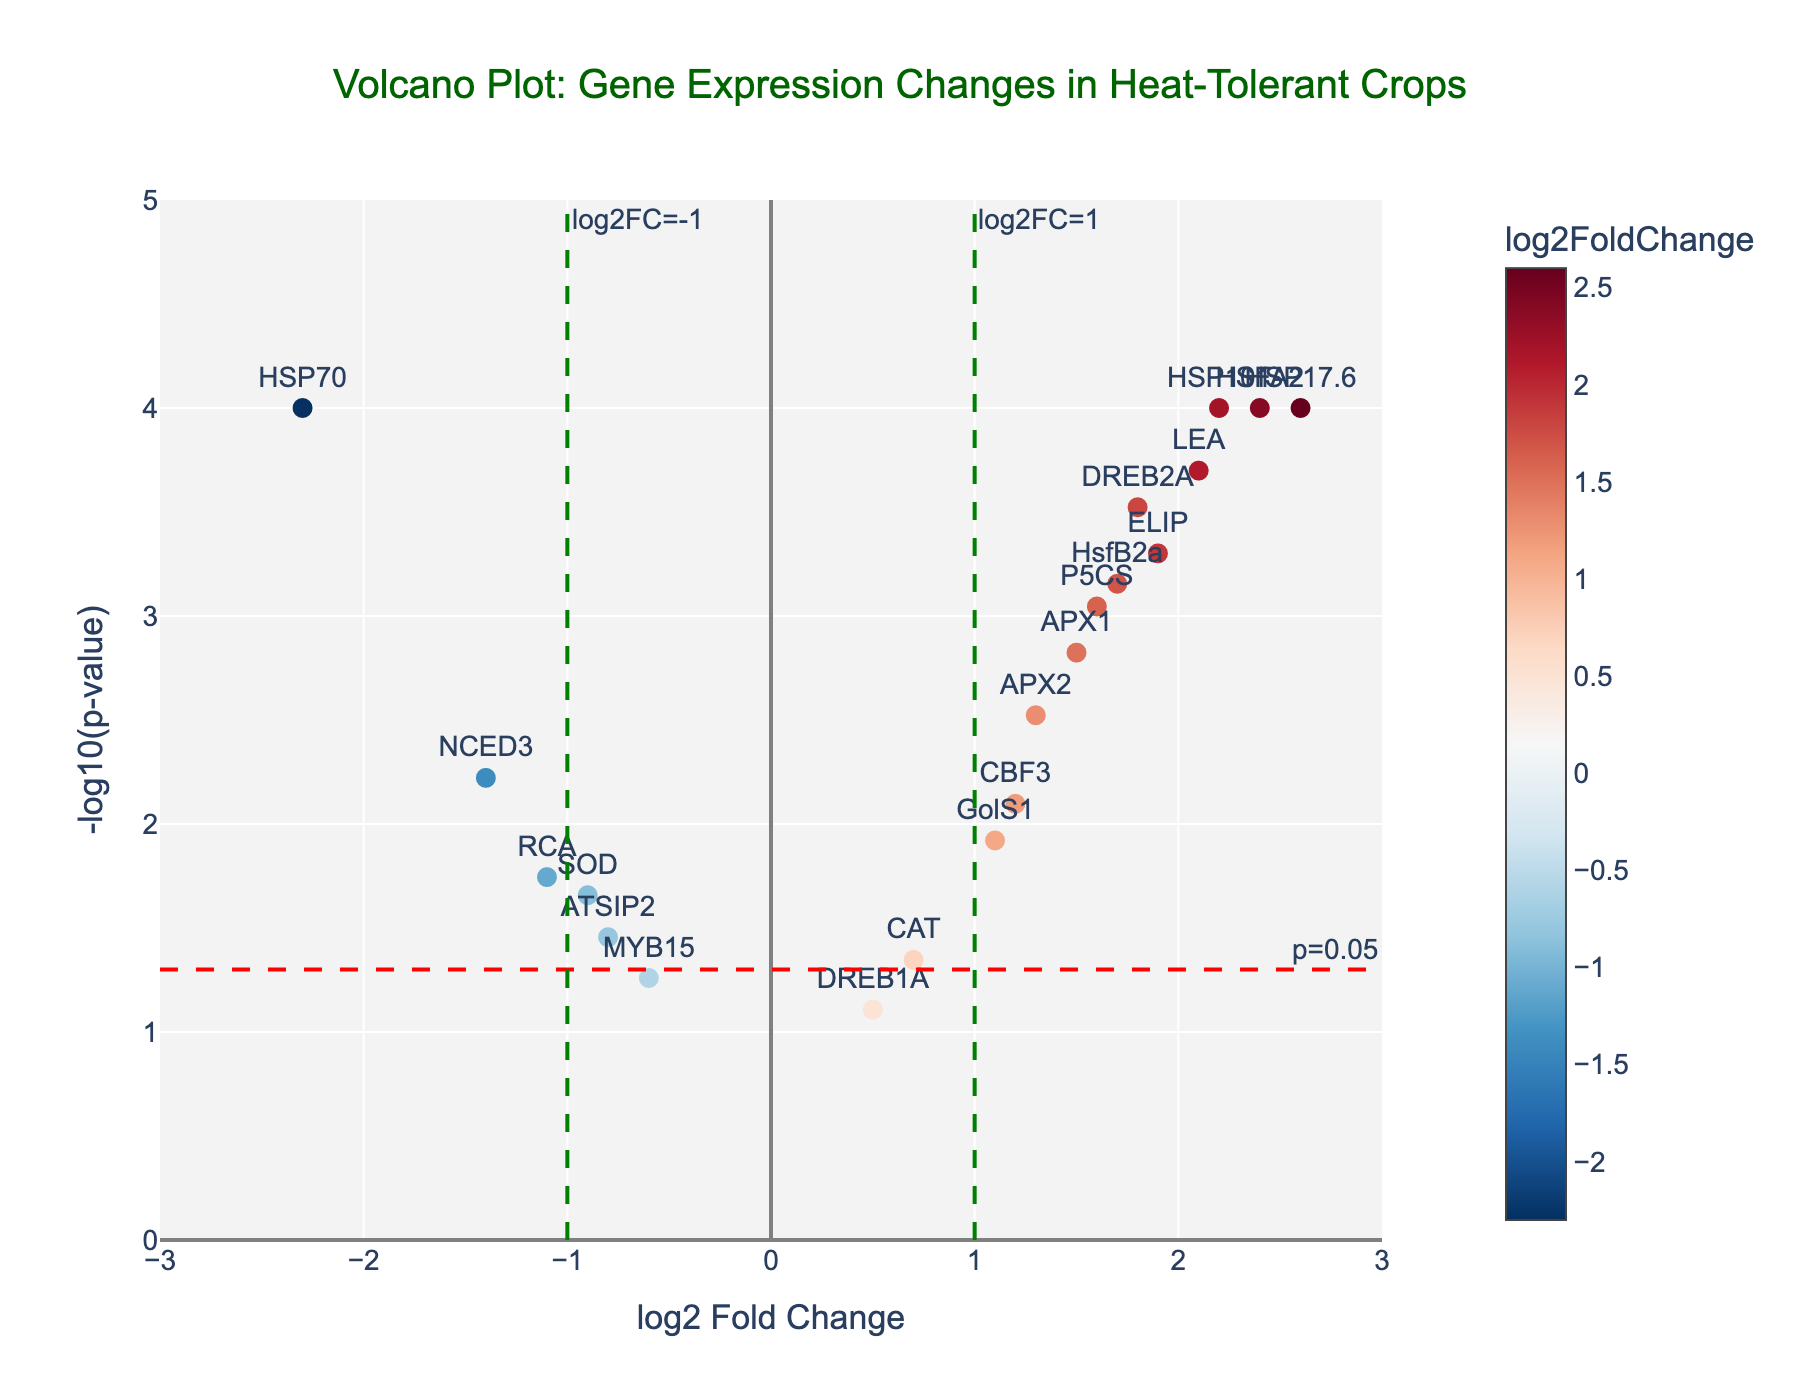What's the title of the plot? The title is located at the top of the plot. It is "Volcano Plot: Gene Expression Changes in Heat-Tolerant Crops".
Answer: Volcano Plot: Gene Expression Changes in Heat-Tolerant Crops What is represented on the x-axis? The x-axis label indicates what it measures. It is "log2 Fold Change".
Answer: log2 Fold Change What value is represented by the horizontal red dashed line? The horizontal dashed line has an annotation that indicates its value. It is labeled "p=0.05".
Answer: p=0.05 Which gene has the highest -log10(p-value)? The highest -log10(p-value) can be found by looking at the y-values of the points and identifying the highest one. The gene associated with this point is "HSP17.6".
Answer: HSP17.6 How many genes have a log2 Fold Change greater than 1? To count the genes with log2 Fold Change greater than 1, look at the points to the right of the vertical green dashed line at x=1.
Answer: 8 Which genes have a log2 Fold Change less than -1 and a p-value below 0.05? Identify the genes that lie to the left of the vertical dashed line at x=-1 and are above the horizontal dashed line at y=-log10(0.05). These genes are "HSP70" and "NCED3".
Answer: HSP70, NCED3 What is the log2 Fold Change of the gene "HSFA2"? The position of the gene "HSFA2" on the x-axis shows its log2 Fold Change. It is around 2.4.
Answer: 2.4 Compare the p-values of "HSP70" and "HSP17.6". Which is smaller? Check the y-values of "HSP70" and "HSP17.6". A higher -log10(p-value) indicates a smaller p-value. "HSP17.6" has a higher y-value (-log10(p-value)), so its p-value is smaller.
Answer: HSP17.6 Which genes have a log2 Fold Change between -1 and 1 and a p-value below 0.05? Look for points within the bounds -1 < log2 Fold Change < 1 and above the horizontal dashed line at y=-log10(0.05). These genes are "CAT", "SOD", "RCA", "ATSIP2", and "GolS1".
Answer: CAT, SOD, RCA, ATSIP2, GolS1 